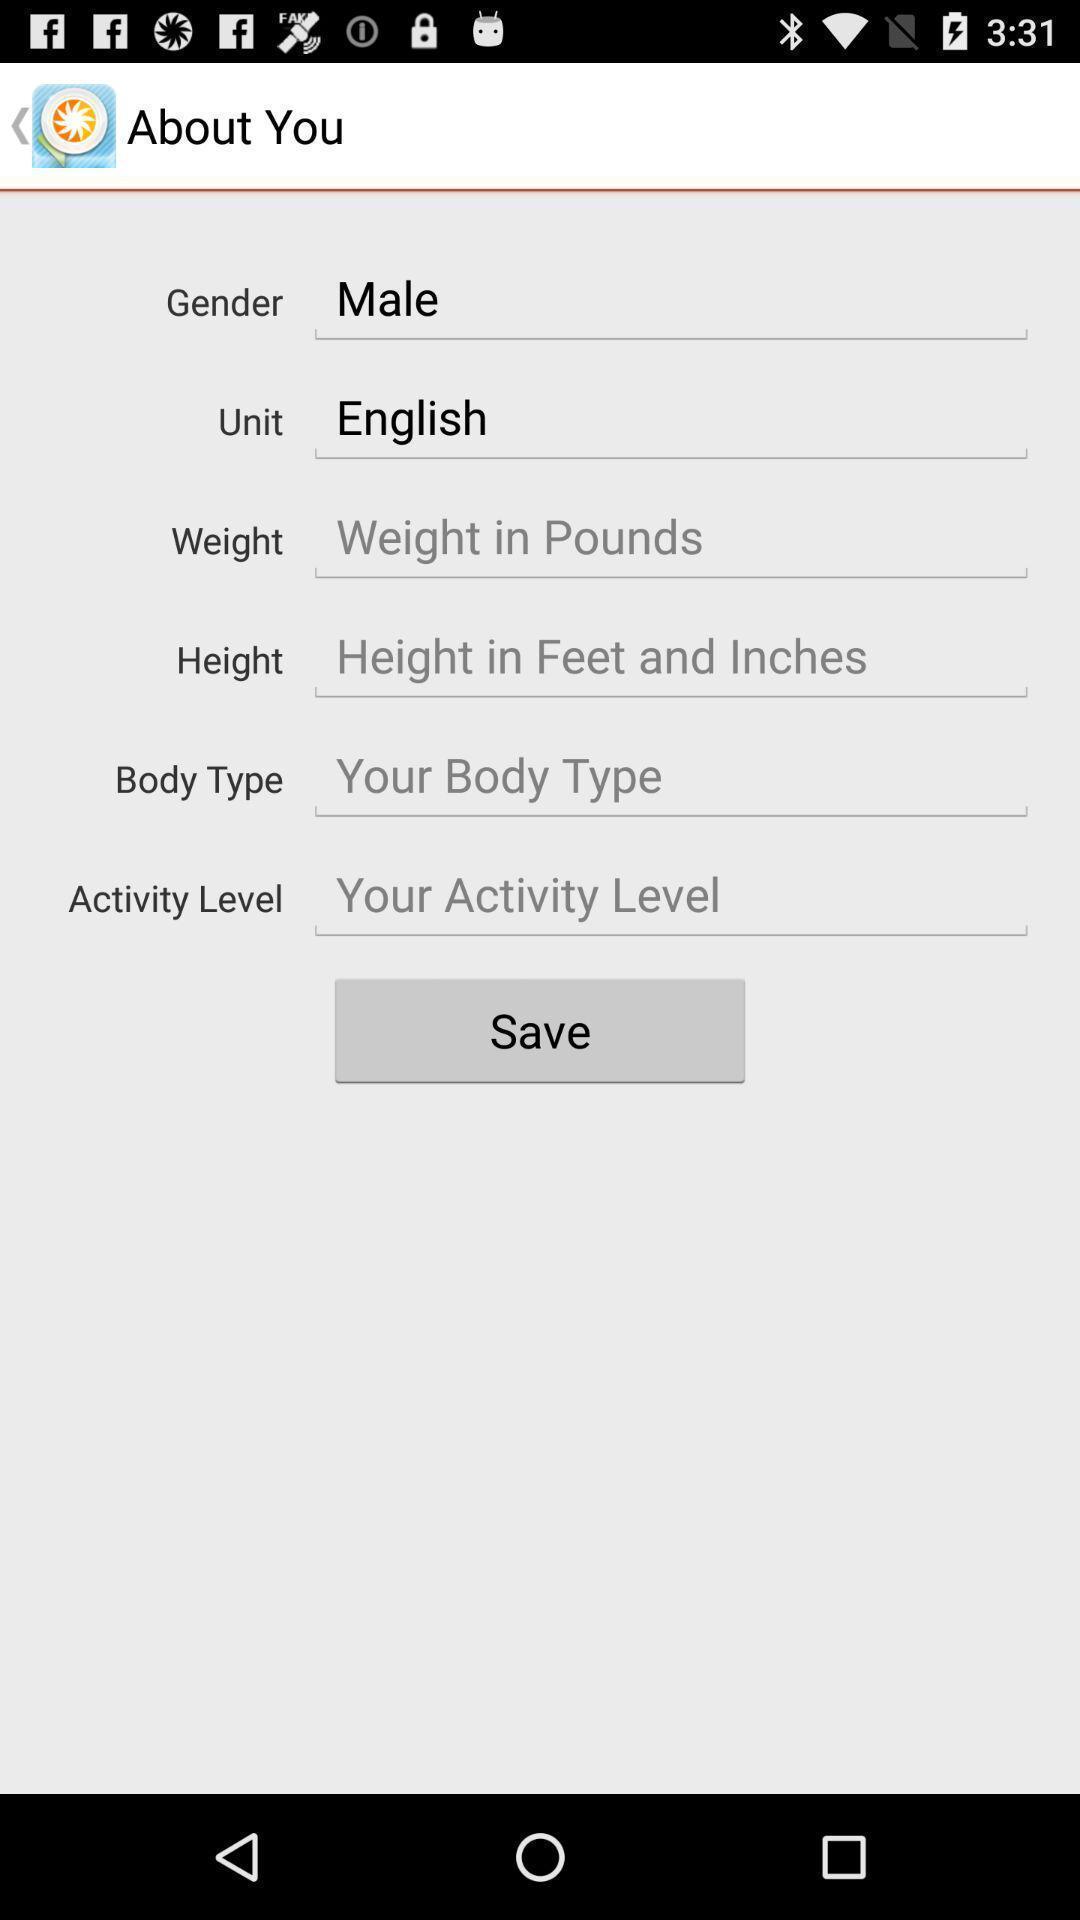What can you discern from this picture? Page displaying various options to be entered. 